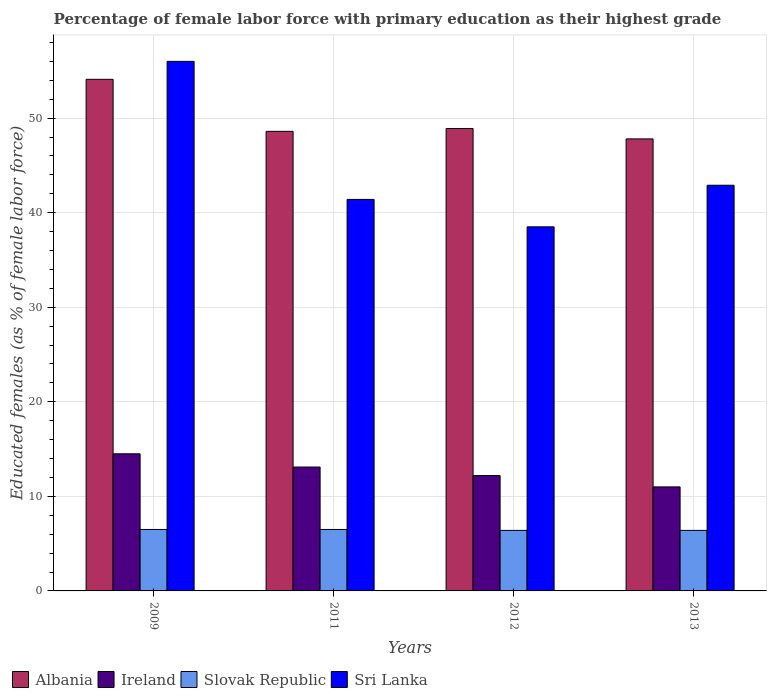How many groups of bars are there?
Your answer should be compact. 4. Are the number of bars per tick equal to the number of legend labels?
Your answer should be compact. Yes. How many bars are there on the 1st tick from the right?
Offer a very short reply. 4. What is the label of the 3rd group of bars from the left?
Offer a terse response. 2012. What is the percentage of female labor force with primary education in Slovak Republic in 2013?
Offer a terse response. 6.4. Across all years, what is the minimum percentage of female labor force with primary education in Slovak Republic?
Offer a terse response. 6.4. What is the total percentage of female labor force with primary education in Slovak Republic in the graph?
Ensure brevity in your answer.  25.8. What is the difference between the percentage of female labor force with primary education in Albania in 2009 and that in 2012?
Make the answer very short. 5.2. What is the difference between the percentage of female labor force with primary education in Ireland in 2012 and the percentage of female labor force with primary education in Slovak Republic in 2013?
Make the answer very short. 5.8. What is the average percentage of female labor force with primary education in Sri Lanka per year?
Your answer should be very brief. 44.7. In the year 2011, what is the difference between the percentage of female labor force with primary education in Ireland and percentage of female labor force with primary education in Sri Lanka?
Offer a terse response. -28.3. What is the ratio of the percentage of female labor force with primary education in Ireland in 2012 to that in 2013?
Ensure brevity in your answer.  1.11. What is the difference between the highest and the second highest percentage of female labor force with primary education in Sri Lanka?
Provide a short and direct response. 13.1. What is the difference between the highest and the lowest percentage of female labor force with primary education in Slovak Republic?
Give a very brief answer. 0.1. In how many years, is the percentage of female labor force with primary education in Sri Lanka greater than the average percentage of female labor force with primary education in Sri Lanka taken over all years?
Keep it short and to the point. 1. What does the 3rd bar from the left in 2012 represents?
Offer a terse response. Slovak Republic. What does the 4th bar from the right in 2009 represents?
Provide a short and direct response. Albania. Does the graph contain any zero values?
Provide a short and direct response. No. Does the graph contain grids?
Your response must be concise. Yes. How are the legend labels stacked?
Offer a very short reply. Horizontal. What is the title of the graph?
Provide a succinct answer. Percentage of female labor force with primary education as their highest grade. Does "Lebanon" appear as one of the legend labels in the graph?
Keep it short and to the point. No. What is the label or title of the Y-axis?
Your answer should be compact. Educated females (as % of female labor force). What is the Educated females (as % of female labor force) of Albania in 2009?
Provide a succinct answer. 54.1. What is the Educated females (as % of female labor force) in Ireland in 2009?
Your response must be concise. 14.5. What is the Educated females (as % of female labor force) of Slovak Republic in 2009?
Make the answer very short. 6.5. What is the Educated females (as % of female labor force) in Albania in 2011?
Provide a succinct answer. 48.6. What is the Educated females (as % of female labor force) in Ireland in 2011?
Make the answer very short. 13.1. What is the Educated females (as % of female labor force) of Slovak Republic in 2011?
Ensure brevity in your answer.  6.5. What is the Educated females (as % of female labor force) of Sri Lanka in 2011?
Make the answer very short. 41.4. What is the Educated females (as % of female labor force) in Albania in 2012?
Offer a very short reply. 48.9. What is the Educated females (as % of female labor force) in Ireland in 2012?
Your answer should be compact. 12.2. What is the Educated females (as % of female labor force) of Slovak Republic in 2012?
Your answer should be very brief. 6.4. What is the Educated females (as % of female labor force) in Sri Lanka in 2012?
Offer a terse response. 38.5. What is the Educated females (as % of female labor force) of Albania in 2013?
Give a very brief answer. 47.8. What is the Educated females (as % of female labor force) of Slovak Republic in 2013?
Your answer should be very brief. 6.4. What is the Educated females (as % of female labor force) in Sri Lanka in 2013?
Offer a very short reply. 42.9. Across all years, what is the maximum Educated females (as % of female labor force) of Albania?
Your answer should be very brief. 54.1. Across all years, what is the maximum Educated females (as % of female labor force) of Slovak Republic?
Ensure brevity in your answer.  6.5. Across all years, what is the minimum Educated females (as % of female labor force) in Albania?
Offer a very short reply. 47.8. Across all years, what is the minimum Educated females (as % of female labor force) of Slovak Republic?
Your response must be concise. 6.4. Across all years, what is the minimum Educated females (as % of female labor force) of Sri Lanka?
Your answer should be compact. 38.5. What is the total Educated females (as % of female labor force) of Albania in the graph?
Offer a very short reply. 199.4. What is the total Educated females (as % of female labor force) of Ireland in the graph?
Ensure brevity in your answer.  50.8. What is the total Educated females (as % of female labor force) in Slovak Republic in the graph?
Keep it short and to the point. 25.8. What is the total Educated females (as % of female labor force) of Sri Lanka in the graph?
Offer a terse response. 178.8. What is the difference between the Educated females (as % of female labor force) of Albania in 2009 and that in 2011?
Your answer should be very brief. 5.5. What is the difference between the Educated females (as % of female labor force) of Ireland in 2009 and that in 2011?
Provide a short and direct response. 1.4. What is the difference between the Educated females (as % of female labor force) of Sri Lanka in 2009 and that in 2011?
Give a very brief answer. 14.6. What is the difference between the Educated females (as % of female labor force) in Albania in 2009 and that in 2012?
Offer a very short reply. 5.2. What is the difference between the Educated females (as % of female labor force) of Slovak Republic in 2009 and that in 2012?
Ensure brevity in your answer.  0.1. What is the difference between the Educated females (as % of female labor force) of Ireland in 2009 and that in 2013?
Offer a very short reply. 3.5. What is the difference between the Educated females (as % of female labor force) in Slovak Republic in 2009 and that in 2013?
Offer a very short reply. 0.1. What is the difference between the Educated females (as % of female labor force) of Sri Lanka in 2009 and that in 2013?
Keep it short and to the point. 13.1. What is the difference between the Educated females (as % of female labor force) of Sri Lanka in 2011 and that in 2012?
Offer a very short reply. 2.9. What is the difference between the Educated females (as % of female labor force) of Ireland in 2011 and that in 2013?
Ensure brevity in your answer.  2.1. What is the difference between the Educated females (as % of female labor force) of Slovak Republic in 2012 and that in 2013?
Provide a short and direct response. 0. What is the difference between the Educated females (as % of female labor force) of Sri Lanka in 2012 and that in 2013?
Your response must be concise. -4.4. What is the difference between the Educated females (as % of female labor force) in Albania in 2009 and the Educated females (as % of female labor force) in Slovak Republic in 2011?
Your response must be concise. 47.6. What is the difference between the Educated females (as % of female labor force) of Albania in 2009 and the Educated females (as % of female labor force) of Sri Lanka in 2011?
Your response must be concise. 12.7. What is the difference between the Educated females (as % of female labor force) of Ireland in 2009 and the Educated females (as % of female labor force) of Sri Lanka in 2011?
Give a very brief answer. -26.9. What is the difference between the Educated females (as % of female labor force) of Slovak Republic in 2009 and the Educated females (as % of female labor force) of Sri Lanka in 2011?
Your answer should be very brief. -34.9. What is the difference between the Educated females (as % of female labor force) in Albania in 2009 and the Educated females (as % of female labor force) in Ireland in 2012?
Provide a succinct answer. 41.9. What is the difference between the Educated females (as % of female labor force) of Albania in 2009 and the Educated females (as % of female labor force) of Slovak Republic in 2012?
Your response must be concise. 47.7. What is the difference between the Educated females (as % of female labor force) of Albania in 2009 and the Educated females (as % of female labor force) of Sri Lanka in 2012?
Give a very brief answer. 15.6. What is the difference between the Educated females (as % of female labor force) in Slovak Republic in 2009 and the Educated females (as % of female labor force) in Sri Lanka in 2012?
Keep it short and to the point. -32. What is the difference between the Educated females (as % of female labor force) in Albania in 2009 and the Educated females (as % of female labor force) in Ireland in 2013?
Offer a very short reply. 43.1. What is the difference between the Educated females (as % of female labor force) of Albania in 2009 and the Educated females (as % of female labor force) of Slovak Republic in 2013?
Your answer should be very brief. 47.7. What is the difference between the Educated females (as % of female labor force) of Ireland in 2009 and the Educated females (as % of female labor force) of Slovak Republic in 2013?
Your answer should be very brief. 8.1. What is the difference between the Educated females (as % of female labor force) of Ireland in 2009 and the Educated females (as % of female labor force) of Sri Lanka in 2013?
Provide a succinct answer. -28.4. What is the difference between the Educated females (as % of female labor force) of Slovak Republic in 2009 and the Educated females (as % of female labor force) of Sri Lanka in 2013?
Your response must be concise. -36.4. What is the difference between the Educated females (as % of female labor force) in Albania in 2011 and the Educated females (as % of female labor force) in Ireland in 2012?
Ensure brevity in your answer.  36.4. What is the difference between the Educated females (as % of female labor force) of Albania in 2011 and the Educated females (as % of female labor force) of Slovak Republic in 2012?
Offer a terse response. 42.2. What is the difference between the Educated females (as % of female labor force) of Ireland in 2011 and the Educated females (as % of female labor force) of Sri Lanka in 2012?
Offer a terse response. -25.4. What is the difference between the Educated females (as % of female labor force) in Slovak Republic in 2011 and the Educated females (as % of female labor force) in Sri Lanka in 2012?
Ensure brevity in your answer.  -32. What is the difference between the Educated females (as % of female labor force) of Albania in 2011 and the Educated females (as % of female labor force) of Ireland in 2013?
Offer a terse response. 37.6. What is the difference between the Educated females (as % of female labor force) in Albania in 2011 and the Educated females (as % of female labor force) in Slovak Republic in 2013?
Offer a terse response. 42.2. What is the difference between the Educated females (as % of female labor force) of Ireland in 2011 and the Educated females (as % of female labor force) of Sri Lanka in 2013?
Offer a very short reply. -29.8. What is the difference between the Educated females (as % of female labor force) in Slovak Republic in 2011 and the Educated females (as % of female labor force) in Sri Lanka in 2013?
Ensure brevity in your answer.  -36.4. What is the difference between the Educated females (as % of female labor force) of Albania in 2012 and the Educated females (as % of female labor force) of Ireland in 2013?
Give a very brief answer. 37.9. What is the difference between the Educated females (as % of female labor force) of Albania in 2012 and the Educated females (as % of female labor force) of Slovak Republic in 2013?
Ensure brevity in your answer.  42.5. What is the difference between the Educated females (as % of female labor force) in Ireland in 2012 and the Educated females (as % of female labor force) in Slovak Republic in 2013?
Provide a succinct answer. 5.8. What is the difference between the Educated females (as % of female labor force) in Ireland in 2012 and the Educated females (as % of female labor force) in Sri Lanka in 2013?
Provide a succinct answer. -30.7. What is the difference between the Educated females (as % of female labor force) in Slovak Republic in 2012 and the Educated females (as % of female labor force) in Sri Lanka in 2013?
Your answer should be very brief. -36.5. What is the average Educated females (as % of female labor force) in Albania per year?
Offer a very short reply. 49.85. What is the average Educated females (as % of female labor force) in Ireland per year?
Ensure brevity in your answer.  12.7. What is the average Educated females (as % of female labor force) of Slovak Republic per year?
Your response must be concise. 6.45. What is the average Educated females (as % of female labor force) of Sri Lanka per year?
Offer a very short reply. 44.7. In the year 2009, what is the difference between the Educated females (as % of female labor force) of Albania and Educated females (as % of female labor force) of Ireland?
Ensure brevity in your answer.  39.6. In the year 2009, what is the difference between the Educated females (as % of female labor force) in Albania and Educated females (as % of female labor force) in Slovak Republic?
Give a very brief answer. 47.6. In the year 2009, what is the difference between the Educated females (as % of female labor force) of Ireland and Educated females (as % of female labor force) of Slovak Republic?
Make the answer very short. 8. In the year 2009, what is the difference between the Educated females (as % of female labor force) in Ireland and Educated females (as % of female labor force) in Sri Lanka?
Your answer should be very brief. -41.5. In the year 2009, what is the difference between the Educated females (as % of female labor force) of Slovak Republic and Educated females (as % of female labor force) of Sri Lanka?
Your response must be concise. -49.5. In the year 2011, what is the difference between the Educated females (as % of female labor force) of Albania and Educated females (as % of female labor force) of Ireland?
Offer a terse response. 35.5. In the year 2011, what is the difference between the Educated females (as % of female labor force) of Albania and Educated females (as % of female labor force) of Slovak Republic?
Keep it short and to the point. 42.1. In the year 2011, what is the difference between the Educated females (as % of female labor force) of Albania and Educated females (as % of female labor force) of Sri Lanka?
Provide a short and direct response. 7.2. In the year 2011, what is the difference between the Educated females (as % of female labor force) of Ireland and Educated females (as % of female labor force) of Slovak Republic?
Your answer should be very brief. 6.6. In the year 2011, what is the difference between the Educated females (as % of female labor force) in Ireland and Educated females (as % of female labor force) in Sri Lanka?
Your response must be concise. -28.3. In the year 2011, what is the difference between the Educated females (as % of female labor force) in Slovak Republic and Educated females (as % of female labor force) in Sri Lanka?
Offer a terse response. -34.9. In the year 2012, what is the difference between the Educated females (as % of female labor force) of Albania and Educated females (as % of female labor force) of Ireland?
Your answer should be very brief. 36.7. In the year 2012, what is the difference between the Educated females (as % of female labor force) in Albania and Educated females (as % of female labor force) in Slovak Republic?
Give a very brief answer. 42.5. In the year 2012, what is the difference between the Educated females (as % of female labor force) of Ireland and Educated females (as % of female labor force) of Sri Lanka?
Give a very brief answer. -26.3. In the year 2012, what is the difference between the Educated females (as % of female labor force) in Slovak Republic and Educated females (as % of female labor force) in Sri Lanka?
Give a very brief answer. -32.1. In the year 2013, what is the difference between the Educated females (as % of female labor force) in Albania and Educated females (as % of female labor force) in Ireland?
Make the answer very short. 36.8. In the year 2013, what is the difference between the Educated females (as % of female labor force) in Albania and Educated females (as % of female labor force) in Slovak Republic?
Offer a terse response. 41.4. In the year 2013, what is the difference between the Educated females (as % of female labor force) in Albania and Educated females (as % of female labor force) in Sri Lanka?
Offer a very short reply. 4.9. In the year 2013, what is the difference between the Educated females (as % of female labor force) in Ireland and Educated females (as % of female labor force) in Sri Lanka?
Make the answer very short. -31.9. In the year 2013, what is the difference between the Educated females (as % of female labor force) in Slovak Republic and Educated females (as % of female labor force) in Sri Lanka?
Provide a short and direct response. -36.5. What is the ratio of the Educated females (as % of female labor force) in Albania in 2009 to that in 2011?
Give a very brief answer. 1.11. What is the ratio of the Educated females (as % of female labor force) of Ireland in 2009 to that in 2011?
Your answer should be very brief. 1.11. What is the ratio of the Educated females (as % of female labor force) in Sri Lanka in 2009 to that in 2011?
Make the answer very short. 1.35. What is the ratio of the Educated females (as % of female labor force) in Albania in 2009 to that in 2012?
Your answer should be compact. 1.11. What is the ratio of the Educated females (as % of female labor force) of Ireland in 2009 to that in 2012?
Keep it short and to the point. 1.19. What is the ratio of the Educated females (as % of female labor force) in Slovak Republic in 2009 to that in 2012?
Your response must be concise. 1.02. What is the ratio of the Educated females (as % of female labor force) in Sri Lanka in 2009 to that in 2012?
Give a very brief answer. 1.45. What is the ratio of the Educated females (as % of female labor force) in Albania in 2009 to that in 2013?
Keep it short and to the point. 1.13. What is the ratio of the Educated females (as % of female labor force) of Ireland in 2009 to that in 2013?
Offer a very short reply. 1.32. What is the ratio of the Educated females (as % of female labor force) in Slovak Republic in 2009 to that in 2013?
Your answer should be compact. 1.02. What is the ratio of the Educated females (as % of female labor force) in Sri Lanka in 2009 to that in 2013?
Keep it short and to the point. 1.31. What is the ratio of the Educated females (as % of female labor force) in Ireland in 2011 to that in 2012?
Provide a short and direct response. 1.07. What is the ratio of the Educated females (as % of female labor force) in Slovak Republic in 2011 to that in 2012?
Provide a short and direct response. 1.02. What is the ratio of the Educated females (as % of female labor force) of Sri Lanka in 2011 to that in 2012?
Provide a short and direct response. 1.08. What is the ratio of the Educated females (as % of female labor force) of Albania in 2011 to that in 2013?
Your answer should be very brief. 1.02. What is the ratio of the Educated females (as % of female labor force) in Ireland in 2011 to that in 2013?
Make the answer very short. 1.19. What is the ratio of the Educated females (as % of female labor force) of Slovak Republic in 2011 to that in 2013?
Ensure brevity in your answer.  1.02. What is the ratio of the Educated females (as % of female labor force) in Sri Lanka in 2011 to that in 2013?
Ensure brevity in your answer.  0.96. What is the ratio of the Educated females (as % of female labor force) in Ireland in 2012 to that in 2013?
Offer a very short reply. 1.11. What is the ratio of the Educated females (as % of female labor force) of Sri Lanka in 2012 to that in 2013?
Keep it short and to the point. 0.9. What is the difference between the highest and the second highest Educated females (as % of female labor force) in Albania?
Your response must be concise. 5.2. What is the difference between the highest and the second highest Educated females (as % of female labor force) of Slovak Republic?
Your response must be concise. 0. What is the difference between the highest and the second highest Educated females (as % of female labor force) in Sri Lanka?
Your answer should be compact. 13.1. What is the difference between the highest and the lowest Educated females (as % of female labor force) of Albania?
Your answer should be very brief. 6.3. 